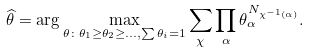Convert formula to latex. <formula><loc_0><loc_0><loc_500><loc_500>\widehat { \theta } = \arg \max _ { \theta \colon \theta _ { 1 } \geq \theta _ { 2 } \geq \dots , \sum \theta _ { i } = 1 } \sum _ { \chi } \prod _ { \alpha } \theta _ { \alpha } ^ { N _ { \chi ^ { - 1 } ( \alpha ) } } .</formula> 